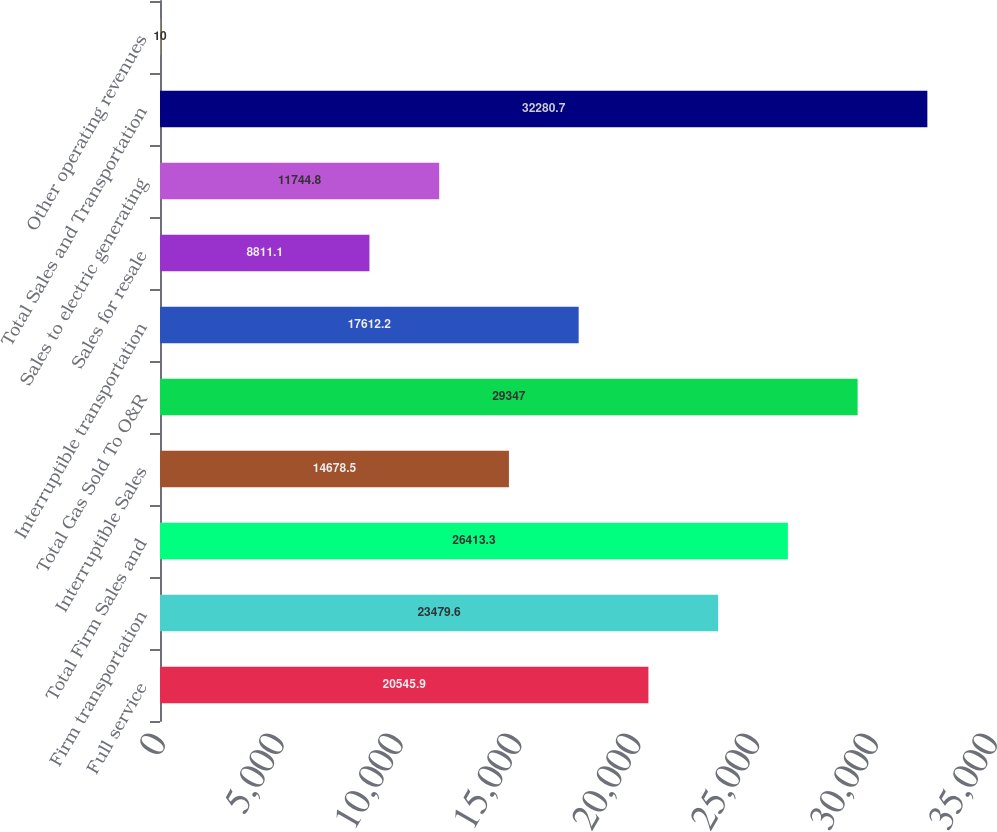Convert chart. <chart><loc_0><loc_0><loc_500><loc_500><bar_chart><fcel>Full service<fcel>Firm transportation<fcel>Total Firm Sales and<fcel>Interruptible Sales<fcel>Total Gas Sold To O&R<fcel>Interruptible transportation<fcel>Sales for resale<fcel>Sales to electric generating<fcel>Total Sales and Transportation<fcel>Other operating revenues<nl><fcel>20545.9<fcel>23479.6<fcel>26413.3<fcel>14678.5<fcel>29347<fcel>17612.2<fcel>8811.1<fcel>11744.8<fcel>32280.7<fcel>10<nl></chart> 